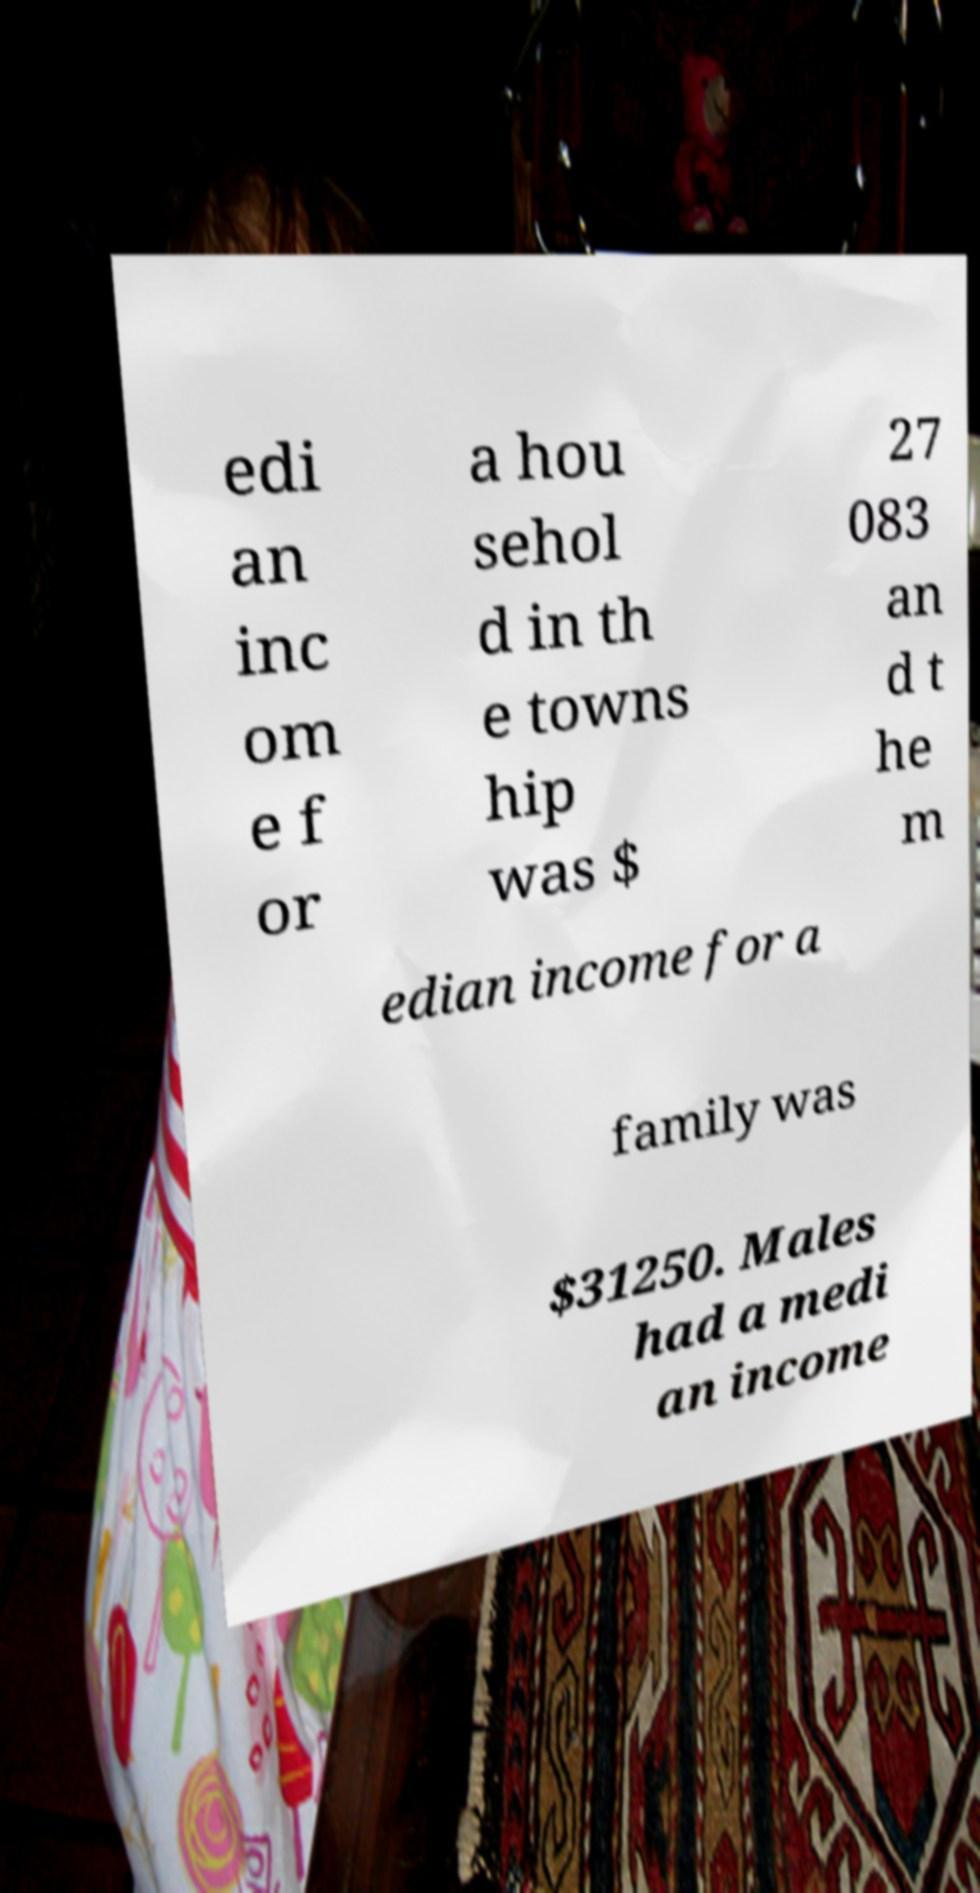Can you accurately transcribe the text from the provided image for me? edi an inc om e f or a hou sehol d in th e towns hip was $ 27 083 an d t he m edian income for a family was $31250. Males had a medi an income 